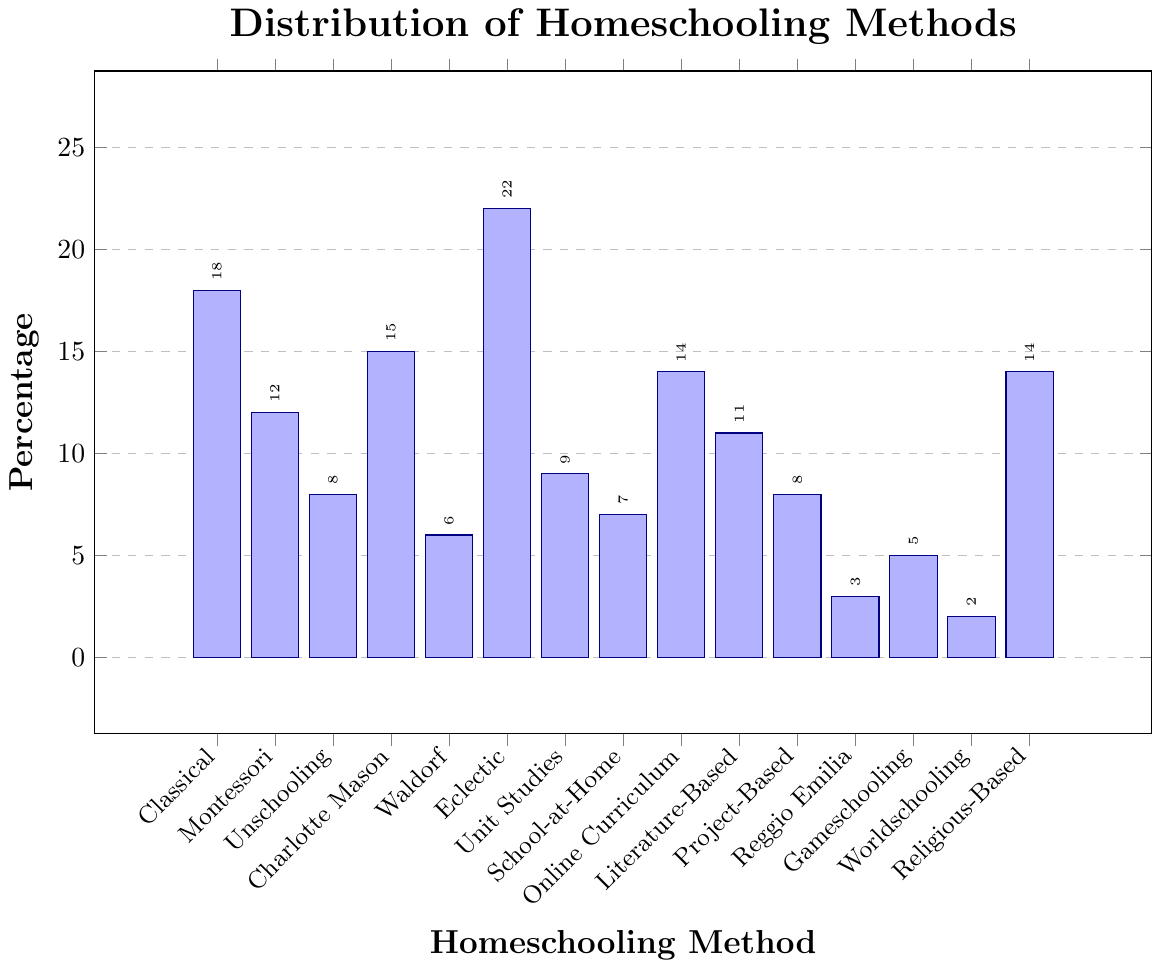Which homeschooling method is the most popular? The tallest bar in the graph represents the most popular homeschooling method. The "Eclectic" method has the highest percentage at 22%.
Answer: Eclectic Which homeschooling methods have a percentage higher than 10%? Look at the bars that extend past the 10% mark on the y-axis. These methods are Classical (18%), Montessori (12%), Charlotte Mason (15%), Online Curriculum (14%), and Religious-Based (14%).
Answer: Classical, Montessori, Charlotte Mason, Online Curriculum, Religious-Based What is the combined percentage of Classical and Montessori methods? Add the percentages of Classical (18%) and Montessori (12%). 18 + 12 = 30
Answer: 30% Which method has the lowest percentage, and what is that percentage? Identify the shortest bar on the graph; this represents the lowest percentage. The "Worldschooling" method has the shortest bar at 2%.
Answer: Worldschooling, 2% How many methods have a percentage lower than 10%? Count the bars that do not reach the 10% mark on the y-axis. These are Unschooling (8%), Waldorf (6%), School-at-Home (7%), Reggio Emilia (3%), Gameschooling (5%), Project-Based (8%), and Worldschooling (2%). There are 7 methods in total.
Answer: 7 Compare the percentage of Religious-Based to Online Curriculum. Which one is higher, and by how much? Look at the heights of the bars for Religious-Based (14%) and Online Curriculum (14%). Since both values are the same, neither one is higher.
Answer: Both are equal What is the average percentage of Unschooling, Charlotte Mason, and Waldorf methods? Add the percentages of Unschooling (8%), Charlotte Mason (15%), and Waldorf (6%) and then divide by 3. (8 + 15 + 6) / 3 = 29 / 3 = 9.67
Answer: 9.67% How does the percentage of Gameschooling compare to that of Unit Studies? Compare the heights of the bars for Gameschooling (5%) and Unit Studies (9%). Unit Studies has a higher percentage.
Answer: Unit Studies is higher by 4% What is the difference in percentage between Eclectic and Project-Based methods? Subtract the percentage of Project-Based (8%) from Eclectic (22%). 22 - 8 = 14
Answer: 14% Which homeschool methods share the same percentage and what is that percentage? Observe the bars at the same height. Online Curriculum and Religious-Based both have a percentage of 14%.
Answer: Online Curriculum, Religious-Based, 14% 